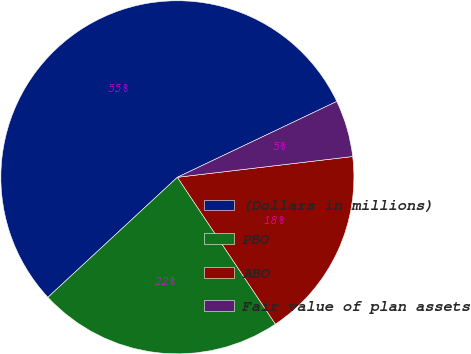<chart> <loc_0><loc_0><loc_500><loc_500><pie_chart><fcel>(Dollars in millions)<fcel>PBO<fcel>ABO<fcel>Fair value of plan assets<nl><fcel>54.83%<fcel>22.47%<fcel>17.51%<fcel>5.19%<nl></chart> 